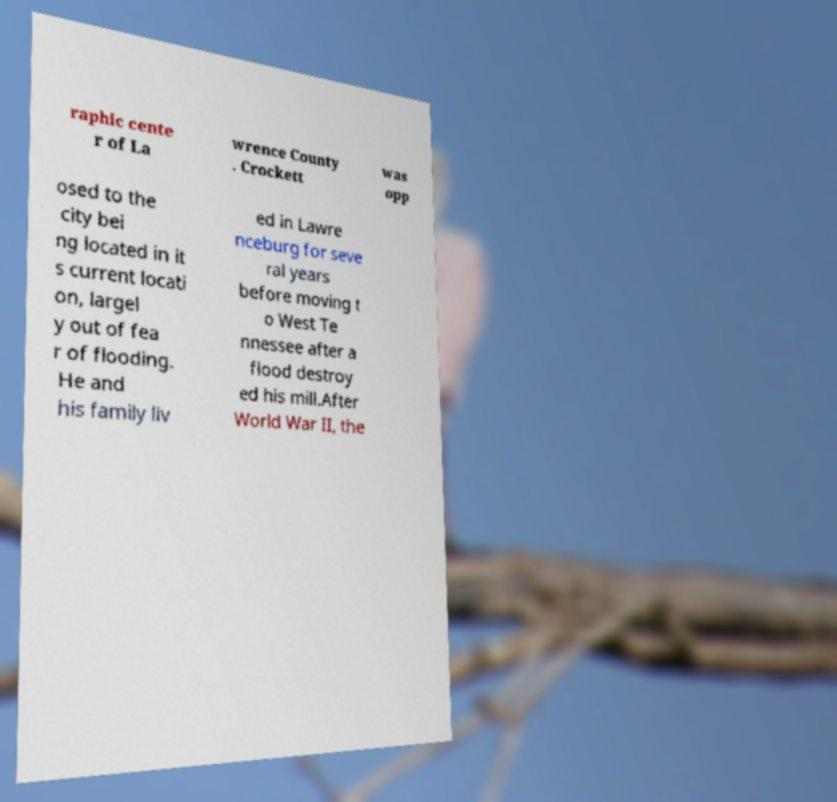Please identify and transcribe the text found in this image. raphic cente r of La wrence County . Crockett was opp osed to the city bei ng located in it s current locati on, largel y out of fea r of flooding. He and his family liv ed in Lawre nceburg for seve ral years before moving t o West Te nnessee after a flood destroy ed his mill.After World War II, the 